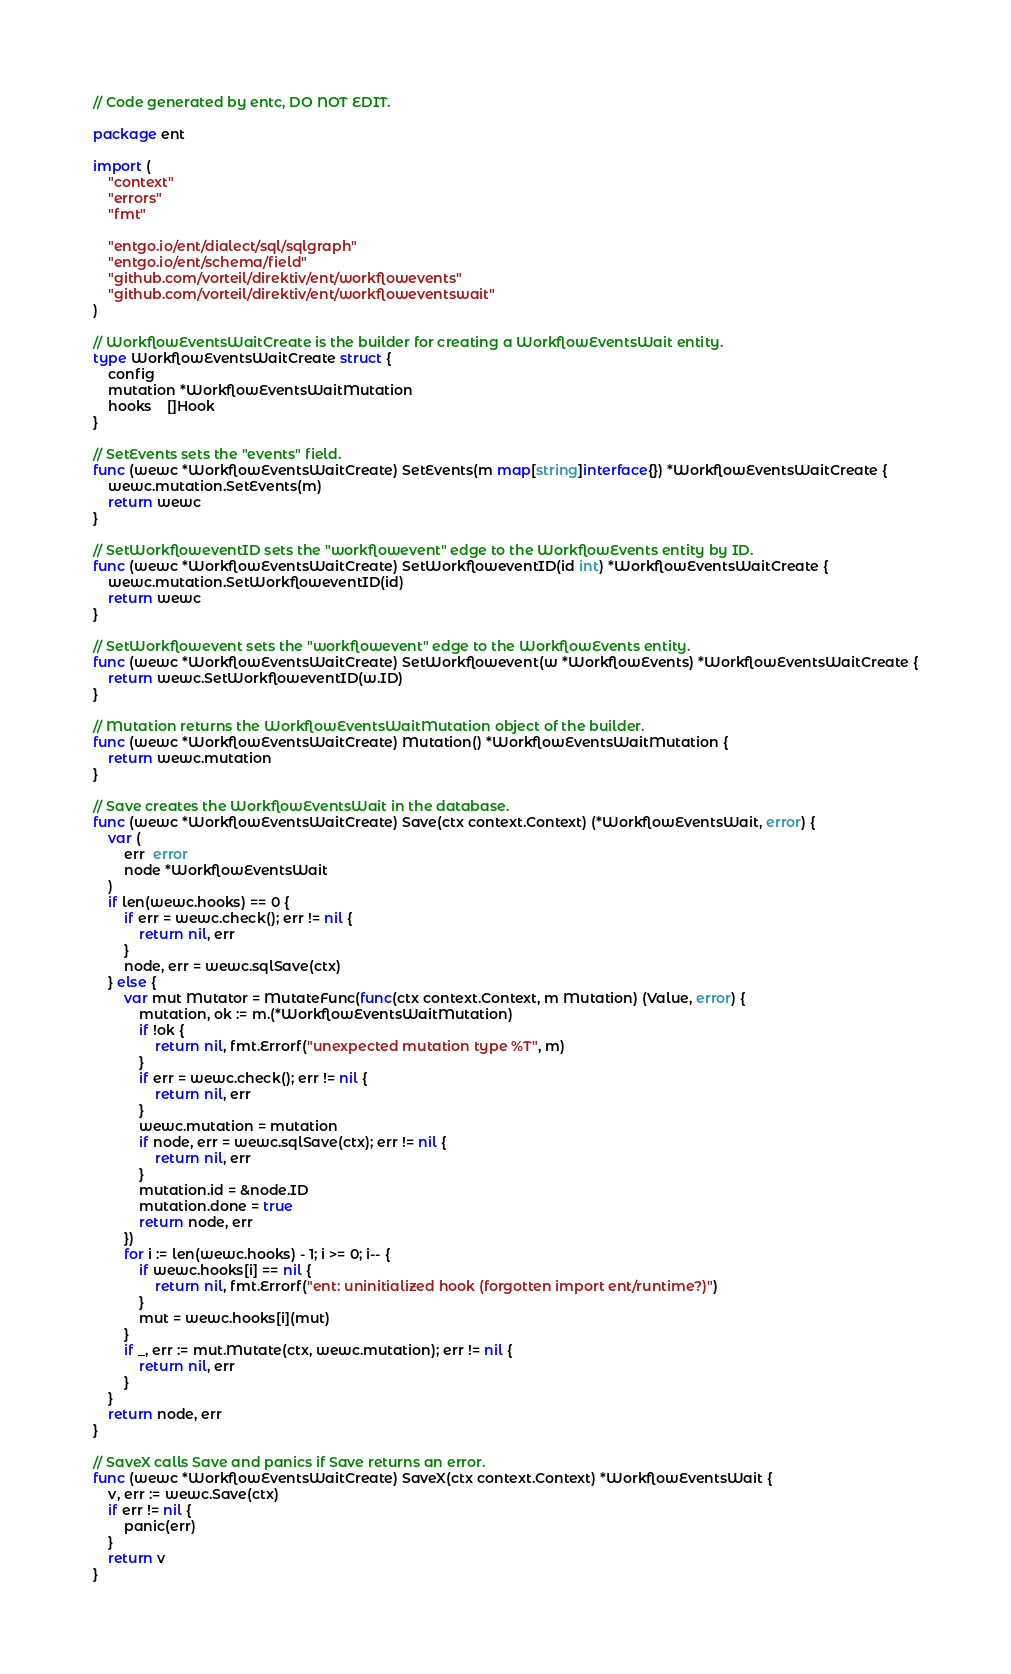<code> <loc_0><loc_0><loc_500><loc_500><_Go_>// Code generated by entc, DO NOT EDIT.

package ent

import (
	"context"
	"errors"
	"fmt"

	"entgo.io/ent/dialect/sql/sqlgraph"
	"entgo.io/ent/schema/field"
	"github.com/vorteil/direktiv/ent/workflowevents"
	"github.com/vorteil/direktiv/ent/workfloweventswait"
)

// WorkflowEventsWaitCreate is the builder for creating a WorkflowEventsWait entity.
type WorkflowEventsWaitCreate struct {
	config
	mutation *WorkflowEventsWaitMutation
	hooks    []Hook
}

// SetEvents sets the "events" field.
func (wewc *WorkflowEventsWaitCreate) SetEvents(m map[string]interface{}) *WorkflowEventsWaitCreate {
	wewc.mutation.SetEvents(m)
	return wewc
}

// SetWorkfloweventID sets the "workflowevent" edge to the WorkflowEvents entity by ID.
func (wewc *WorkflowEventsWaitCreate) SetWorkfloweventID(id int) *WorkflowEventsWaitCreate {
	wewc.mutation.SetWorkfloweventID(id)
	return wewc
}

// SetWorkflowevent sets the "workflowevent" edge to the WorkflowEvents entity.
func (wewc *WorkflowEventsWaitCreate) SetWorkflowevent(w *WorkflowEvents) *WorkflowEventsWaitCreate {
	return wewc.SetWorkfloweventID(w.ID)
}

// Mutation returns the WorkflowEventsWaitMutation object of the builder.
func (wewc *WorkflowEventsWaitCreate) Mutation() *WorkflowEventsWaitMutation {
	return wewc.mutation
}

// Save creates the WorkflowEventsWait in the database.
func (wewc *WorkflowEventsWaitCreate) Save(ctx context.Context) (*WorkflowEventsWait, error) {
	var (
		err  error
		node *WorkflowEventsWait
	)
	if len(wewc.hooks) == 0 {
		if err = wewc.check(); err != nil {
			return nil, err
		}
		node, err = wewc.sqlSave(ctx)
	} else {
		var mut Mutator = MutateFunc(func(ctx context.Context, m Mutation) (Value, error) {
			mutation, ok := m.(*WorkflowEventsWaitMutation)
			if !ok {
				return nil, fmt.Errorf("unexpected mutation type %T", m)
			}
			if err = wewc.check(); err != nil {
				return nil, err
			}
			wewc.mutation = mutation
			if node, err = wewc.sqlSave(ctx); err != nil {
				return nil, err
			}
			mutation.id = &node.ID
			mutation.done = true
			return node, err
		})
		for i := len(wewc.hooks) - 1; i >= 0; i-- {
			if wewc.hooks[i] == nil {
				return nil, fmt.Errorf("ent: uninitialized hook (forgotten import ent/runtime?)")
			}
			mut = wewc.hooks[i](mut)
		}
		if _, err := mut.Mutate(ctx, wewc.mutation); err != nil {
			return nil, err
		}
	}
	return node, err
}

// SaveX calls Save and panics if Save returns an error.
func (wewc *WorkflowEventsWaitCreate) SaveX(ctx context.Context) *WorkflowEventsWait {
	v, err := wewc.Save(ctx)
	if err != nil {
		panic(err)
	}
	return v
}
</code> 